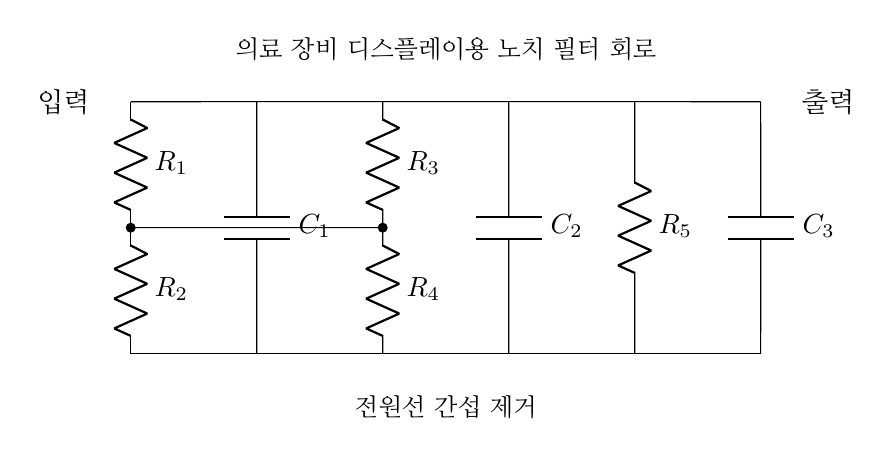What components are present in this circuit? The diagram shows resistors (R1, R2, R3, R4, R5), capacitors (C1, C2, C3), and connections between them.
Answer: resistors and capacitors What is the role of the capacitors in this notch filter circuit? Capacitors in a notch filter are used to block specific frequencies, allowing the circuit to filter out unwanted noise, such as power line interference.
Answer: noise filtering How many resistors are there in the circuit? By counting each label, we see that five resistors are drawn in the diagram (R1, R2, R3, R4, R5).
Answer: five What is the input and output configuration of this circuit? The input is connected to the top row of the circuit diagram, and the output originates from the same top row, indicating a direct connection from input to output through the filter components.
Answer: top row connection Which components form the low-frequency bypass in the circuit? The arrangement of capacitors C1 and C3 alongside resistors forms the low-frequency bypass, allowing lower frequencies to be shunted while the desired signal is passed.
Answer: C1 and C3 How is the notch filter specifically beneficial for medical equipment displays? A notch filter effectively eliminates power line interference, ensuring that medical displays show accurate and clean readings, which is crucial for patient monitoring.
Answer: interference removal What is the primary function of the R1 and R2 combination in this circuit? Resistors R1 and R2 work together to form a voltage divider, which helps maintain the correct output level while isolating the filtering effects from the input.
Answer: voltage divider 